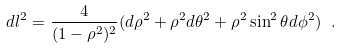Convert formula to latex. <formula><loc_0><loc_0><loc_500><loc_500>d l ^ { 2 } = \frac { 4 } { ( 1 - { \rho } ^ { 2 } ) ^ { 2 } } ( d { \rho } ^ { 2 } + { \rho } ^ { 2 } d { \theta } ^ { 2 } + { \rho } ^ { 2 } \sin ^ { 2 } { \theta } d { \phi } ^ { 2 } ) \ .</formula> 